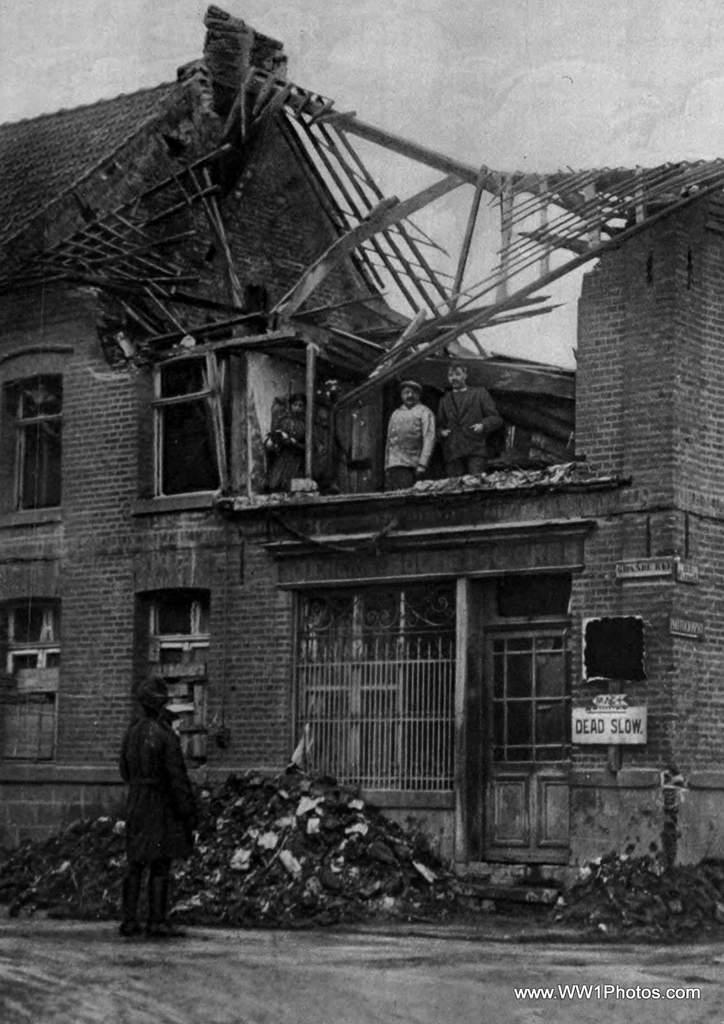What is the main structure in the image? There is a building in the image. What features can be observed on the building? The building has windows and people standing on it. Is there an entrance to the building visible in the image? Yes, there is a door in the image. What can be seen on the building to indicate its purpose or identity? Name boards are present in the image. What is visible in the background of the image? The sky is visible in the background of the image. What type of punishment is being administered to the people standing on the building in the image? There is no indication of punishment in the image; the people are simply standing on the building. How does the selection process work for the people standing on the building in the image? There is no selection process visible in the image. 